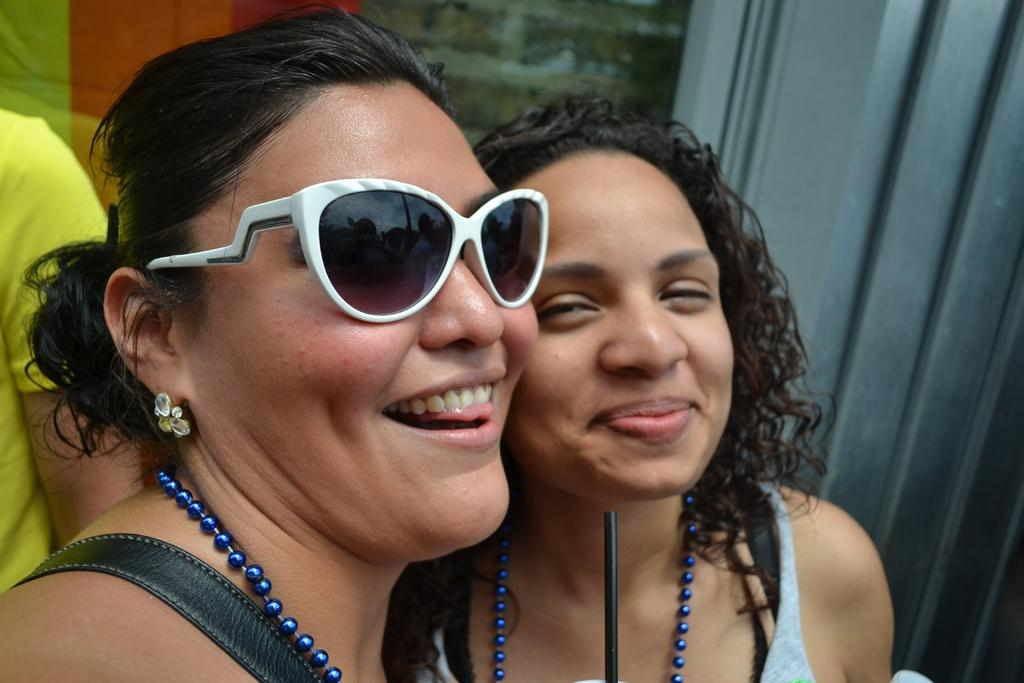How many women are in the foreground of the image? There are two women in the foreground of the image. What are the women doing in the image? The women are smiling in the image. What is the first woman wearing? The first woman is wearing goggles. Can you describe the person behind the women? There appears to be a man behind the women in the image. What type of reward can be seen hanging from the wire in the image? There is no wire or reward present in the image. What is the moon's position in the image? The moon is not visible in the image. 